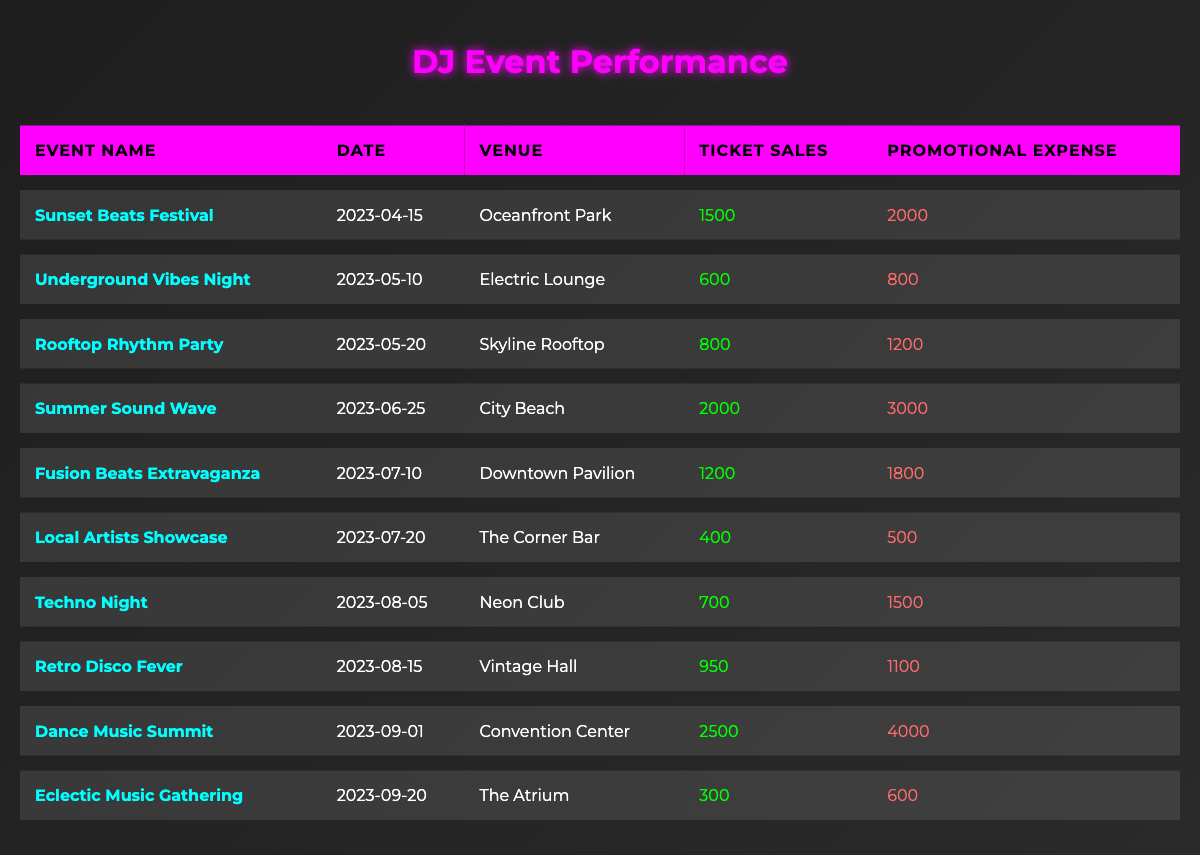What is the total ticket sales for all events? To find the total ticket sales, we add the ticket sales from each event: 1500 + 600 + 800 + 2000 + 1200 + 400 + 700 + 950 + 2500 + 300 = 10150.
Answer: 10150 Which event had the highest promotional expense? We compare the promotional expenses: the highest value is 4000 for the "Dance Music Summit."
Answer: Dance Music Summit What was the average ticket sales across all events? We sum up the ticket sales (10150) and divide by the number of events (10): 10150 / 10 = 1015.
Answer: 1015 Was the promotional expense for the "Rooftop Rhythm Party" greater than its ticket sales? The promotional expense for the "Rooftop Rhythm Party" is 1200 and ticket sales are 800, so 1200 > 800 is true.
Answer: Yes How much more were the total ticket sales than the total promotional expenses? Total ticket sales are 10150 and total promotional expenses are 19100 (2000 + 800 + 1200 + 3000 + 1800 + 500 + 1500 + 1100 + 4000 + 600 = 19100). The difference is 10150 - 19100 = -8950, indicating the sales were less than the expenses.
Answer: -8950 What was the ticket sales amount for the event held on June 25, 2023? The ticket sales for "Summer Sound Wave," held on June 25, 2023, are 2000.
Answer: 2000 Which event was held at "Neon Club"? The event at "Neon Club" is "Techno Night", held on August 5, 2023.
Answer: Techno Night What is the total promotional expense for events that had ticket sales below 1000? We check events with ticket sales less than 1000. They are "Underground Vibes Night," "Rooftop Rhythm Party," "Local Artists Showcase," "Techno Night," and "Eclectic Music Gathering." Their promotional expenses sum up to 800 + 1200 + 500 + 1500 + 600 = 3600.
Answer: 3600 Are there any events with equal ticket sales and promotional expenses? We find no events where ticket sales equal promotional expenses; all the events show a difference between ticket sales and promotional expenses.
Answer: No Which venue hosted the event with the lowest ticket sales? The event with the lowest ticket sales is "Eclectic Music Gathering," with 300 tickets sold, hosted at "The Atrium."
Answer: The Atrium 